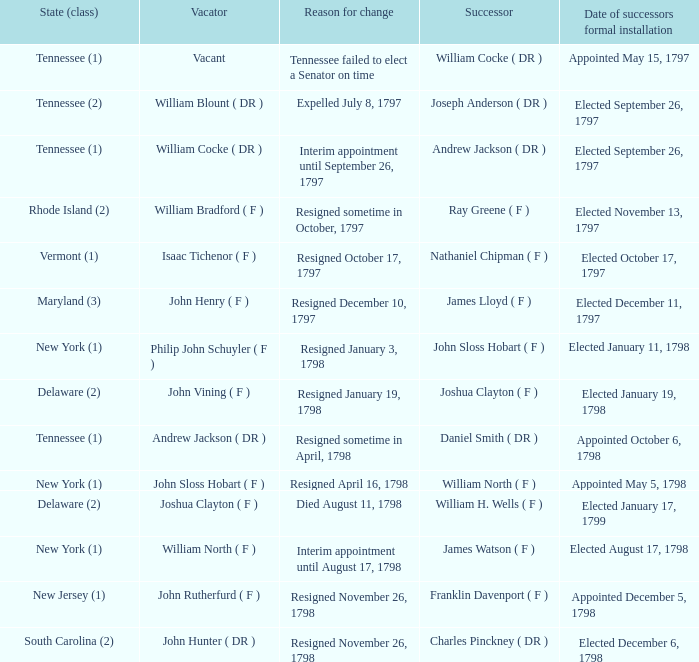What are all the states (class) when the rationale for adjustment was quitting on november 26, 1798, and the individual vacating was john hunter (dr)? South Carolina (2). Could you parse the entire table? {'header': ['State (class)', 'Vacator', 'Reason for change', 'Successor', 'Date of successors formal installation'], 'rows': [['Tennessee (1)', 'Vacant', 'Tennessee failed to elect a Senator on time', 'William Cocke ( DR )', 'Appointed May 15, 1797'], ['Tennessee (2)', 'William Blount ( DR )', 'Expelled July 8, 1797', 'Joseph Anderson ( DR )', 'Elected September 26, 1797'], ['Tennessee (1)', 'William Cocke ( DR )', 'Interim appointment until September 26, 1797', 'Andrew Jackson ( DR )', 'Elected September 26, 1797'], ['Rhode Island (2)', 'William Bradford ( F )', 'Resigned sometime in October, 1797', 'Ray Greene ( F )', 'Elected November 13, 1797'], ['Vermont (1)', 'Isaac Tichenor ( F )', 'Resigned October 17, 1797', 'Nathaniel Chipman ( F )', 'Elected October 17, 1797'], ['Maryland (3)', 'John Henry ( F )', 'Resigned December 10, 1797', 'James Lloyd ( F )', 'Elected December 11, 1797'], ['New York (1)', 'Philip John Schuyler ( F )', 'Resigned January 3, 1798', 'John Sloss Hobart ( F )', 'Elected January 11, 1798'], ['Delaware (2)', 'John Vining ( F )', 'Resigned January 19, 1798', 'Joshua Clayton ( F )', 'Elected January 19, 1798'], ['Tennessee (1)', 'Andrew Jackson ( DR )', 'Resigned sometime in April, 1798', 'Daniel Smith ( DR )', 'Appointed October 6, 1798'], ['New York (1)', 'John Sloss Hobart ( F )', 'Resigned April 16, 1798', 'William North ( F )', 'Appointed May 5, 1798'], ['Delaware (2)', 'Joshua Clayton ( F )', 'Died August 11, 1798', 'William H. Wells ( F )', 'Elected January 17, 1799'], ['New York (1)', 'William North ( F )', 'Interim appointment until August 17, 1798', 'James Watson ( F )', 'Elected August 17, 1798'], ['New Jersey (1)', 'John Rutherfurd ( F )', 'Resigned November 26, 1798', 'Franklin Davenport ( F )', 'Appointed December 5, 1798'], ['South Carolina (2)', 'John Hunter ( DR )', 'Resigned November 26, 1798', 'Charles Pinckney ( DR )', 'Elected December 6, 1798']]} 